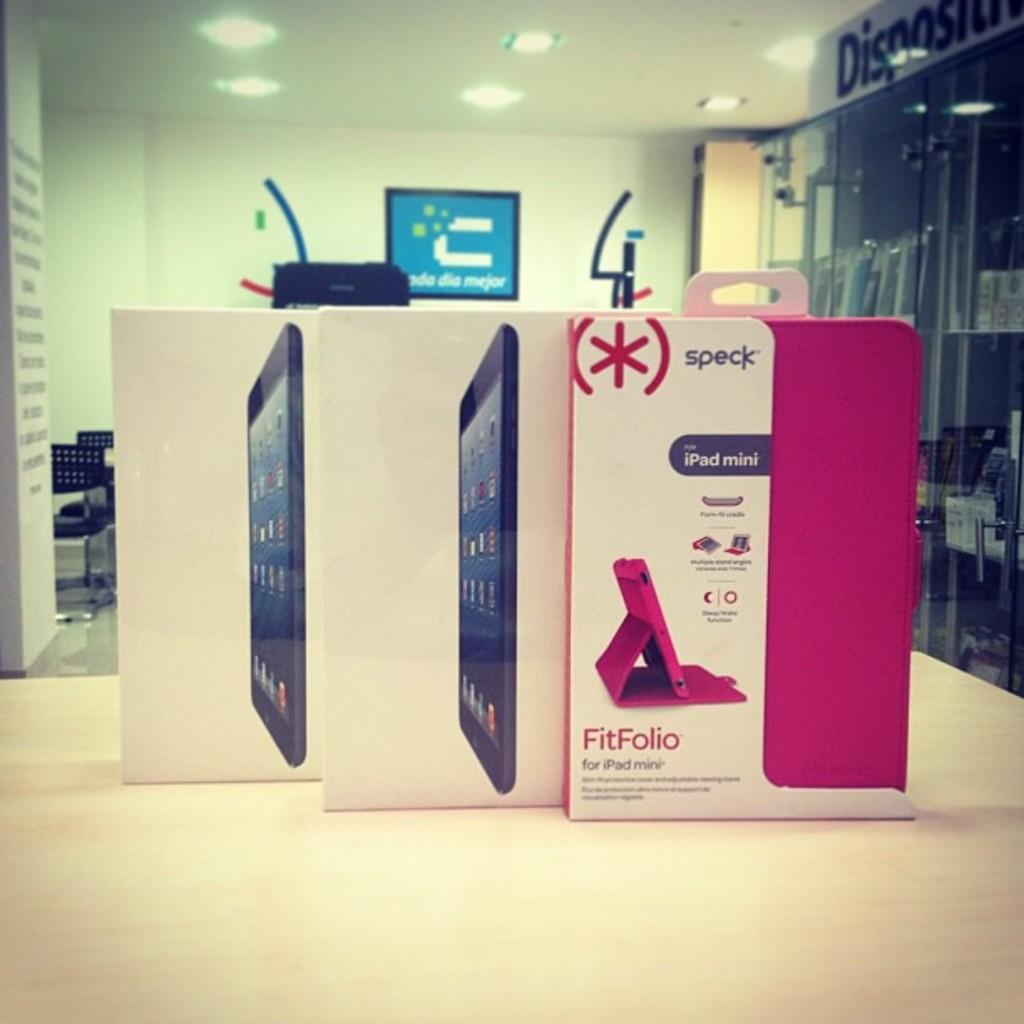Provide a one-sentence caption for the provided image. A box for a case for an iPad min is shown in pink with the brand name speck. 